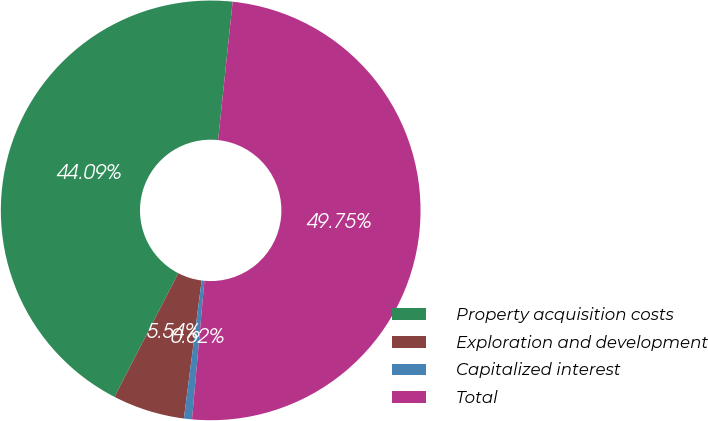<chart> <loc_0><loc_0><loc_500><loc_500><pie_chart><fcel>Property acquisition costs<fcel>Exploration and development<fcel>Capitalized interest<fcel>Total<nl><fcel>44.09%<fcel>5.54%<fcel>0.62%<fcel>49.75%<nl></chart> 